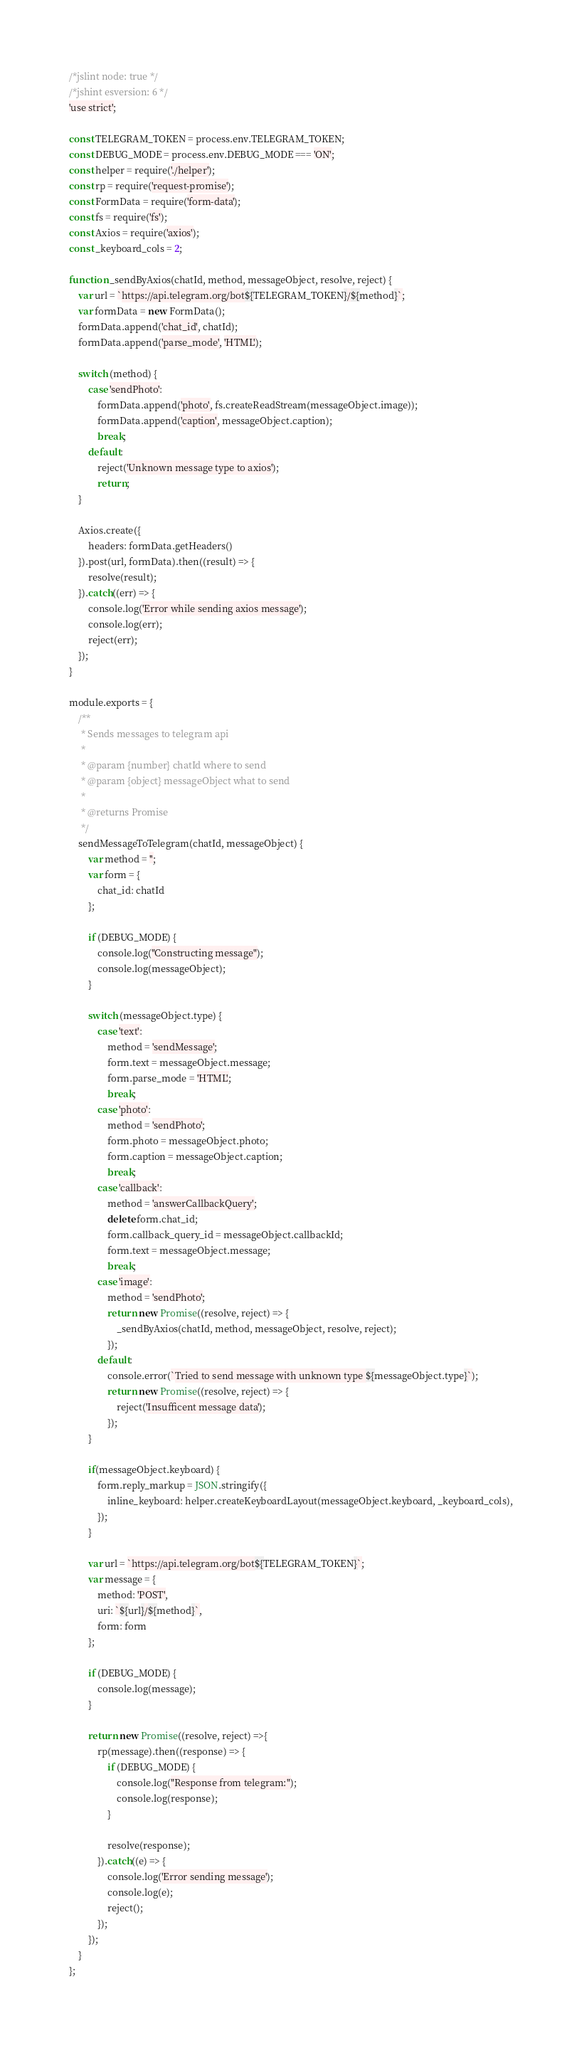<code> <loc_0><loc_0><loc_500><loc_500><_JavaScript_>/*jslint node: true */
/*jshint esversion: 6 */
'use strict';

const TELEGRAM_TOKEN = process.env.TELEGRAM_TOKEN;
const DEBUG_MODE = process.env.DEBUG_MODE === 'ON';
const helper = require('./helper');
const rp = require('request-promise');
const FormData = require('form-data');
const fs = require('fs');
const Axios = require('axios');
const _keyboard_cols = 2;

function _sendByAxios(chatId, method, messageObject, resolve, reject) {
    var url = `https://api.telegram.org/bot${TELEGRAM_TOKEN}/${method}`;
    var formData = new FormData();
    formData.append('chat_id', chatId);
    formData.append('parse_mode', 'HTML');

    switch (method) {
        case 'sendPhoto':
            formData.append('photo', fs.createReadStream(messageObject.image));
            formData.append('caption', messageObject.caption);
            break;
        default:
            reject('Unknown message type to axios');
            return;
    }

    Axios.create({
        headers: formData.getHeaders()
    }).post(url, formData).then((result) => {
        resolve(result);
    }).catch((err) => {
        console.log('Error while sending axios message');
        console.log(err);
        reject(err);
    });
}

module.exports = {
    /**
     * Sends messages to telegram api
     *
     * @param {number} chatId where to send
     * @param {object} messageObject what to send
     *
     * @returns Promise
     */
    sendMessageToTelegram(chatId, messageObject) {
        var method = '';
        var form = {
            chat_id: chatId
        };

        if (DEBUG_MODE) {
            console.log("Constructing message");
            console.log(messageObject);
        }

        switch (messageObject.type) {
            case 'text':
                method = 'sendMessage';
                form.text = messageObject.message;
                form.parse_mode = 'HTML';
                break;
            case 'photo':
                method = 'sendPhoto';
                form.photo = messageObject.photo;
                form.caption = messageObject.caption;
                break;
            case 'callback':
                method = 'answerCallbackQuery';
                delete form.chat_id;
                form.callback_query_id = messageObject.callbackId;
                form.text = messageObject.message;
                break;
            case 'image':
                method = 'sendPhoto';
                return new Promise((resolve, reject) => {
                    _sendByAxios(chatId, method, messageObject, resolve, reject);
                });
            default:
                console.error(`Tried to send message with unknown type ${messageObject.type}`);
                return new Promise((resolve, reject) => {
                    reject('Insufficent message data');
                });
        }

        if(messageObject.keyboard) {
            form.reply_markup = JSON.stringify({
                inline_keyboard: helper.createKeyboardLayout(messageObject.keyboard, _keyboard_cols),
            });
        }

        var url = `https://api.telegram.org/bot${TELEGRAM_TOKEN}`;
        var message = {
            method: 'POST',
            uri: `${url}/${method}`,
            form: form
        };

        if (DEBUG_MODE) {
            console.log(message);
        }

        return new Promise((resolve, reject) =>{
            rp(message).then((response) => {
                if (DEBUG_MODE) {
                    console.log("Response from telegram:");
                    console.log(response);
                }

                resolve(response);
            }).catch((e) => {
                console.log('Error sending message');
                console.log(e);
                reject();
            });
        });
    }
};</code> 